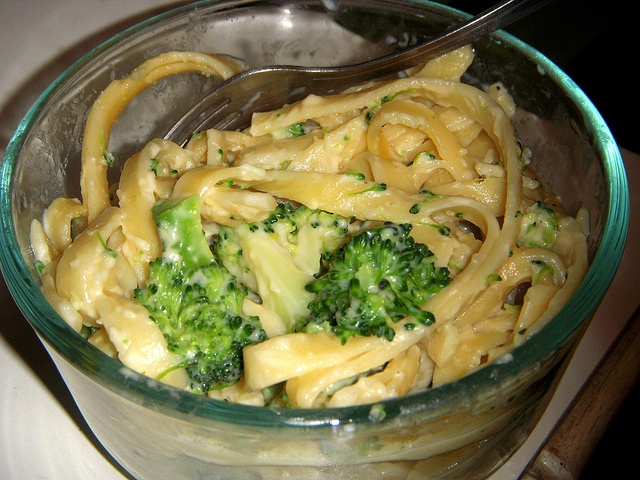Describe the objects in this image and their specific colors. I can see bowl in gray, olive, and black tones, dining table in gray, black, lightgray, and maroon tones, broccoli in gray, olive, and darkgreen tones, broccoli in gray, darkgreen, olive, and green tones, and fork in gray, black, and olive tones in this image. 